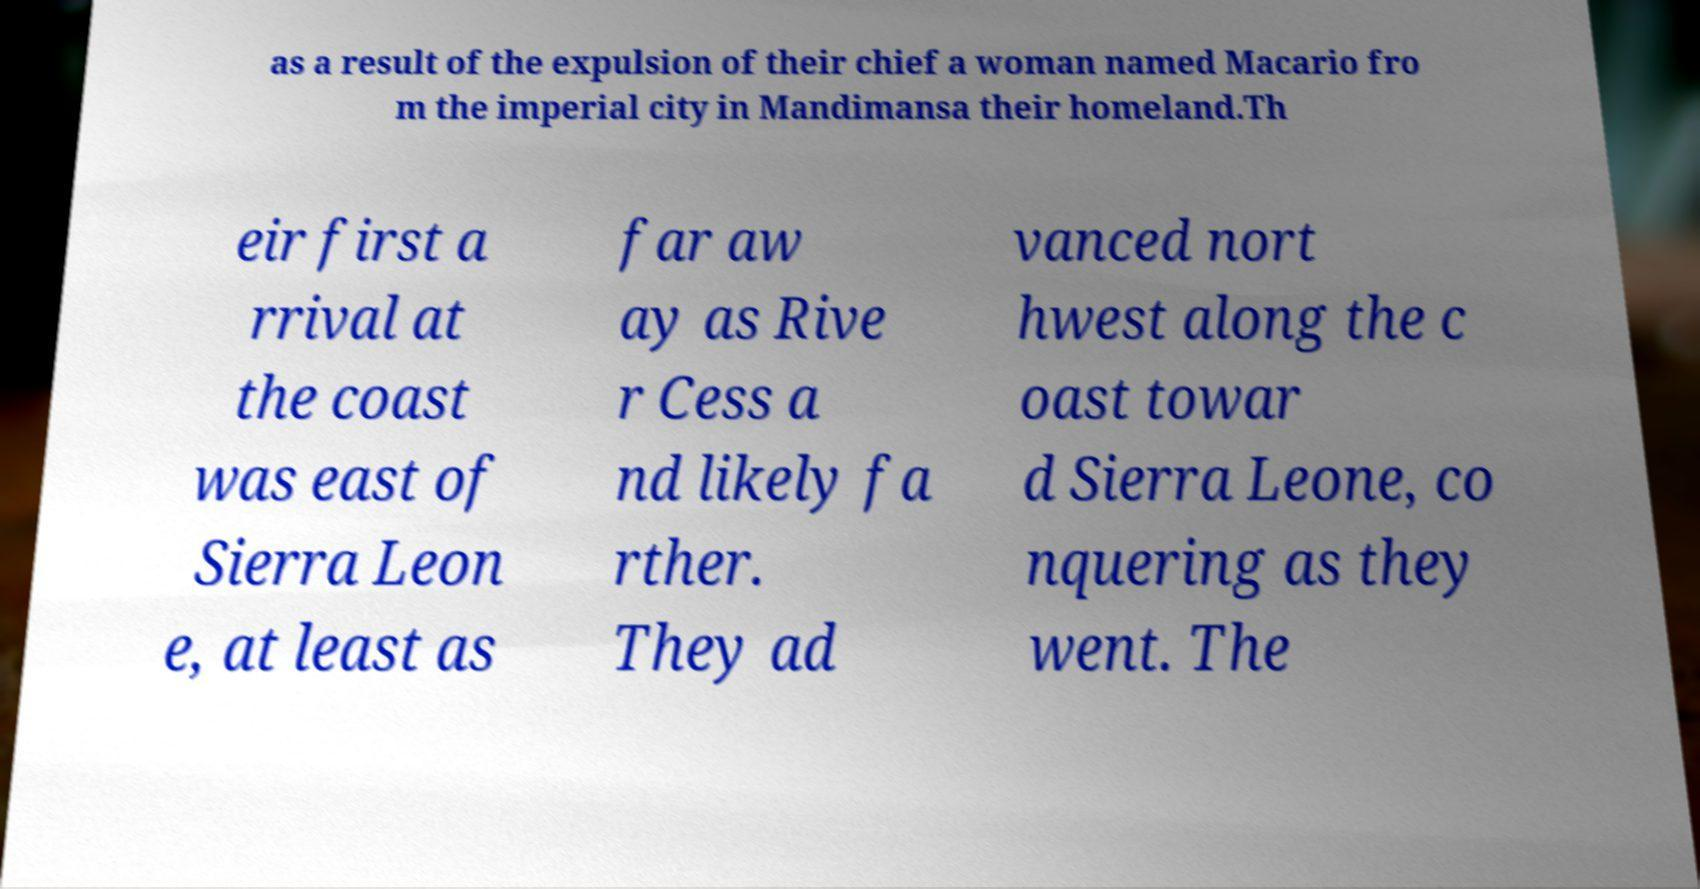Please read and relay the text visible in this image. What does it say? as a result of the expulsion of their chief a woman named Macario fro m the imperial city in Mandimansa their homeland.Th eir first a rrival at the coast was east of Sierra Leon e, at least as far aw ay as Rive r Cess a nd likely fa rther. They ad vanced nort hwest along the c oast towar d Sierra Leone, co nquering as they went. The 